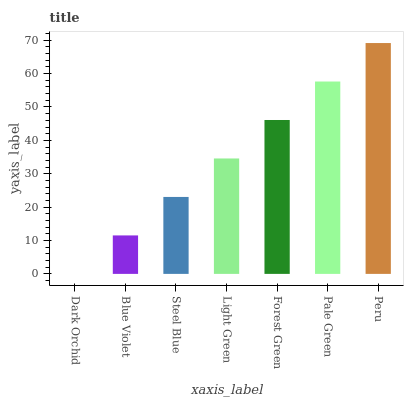Is Dark Orchid the minimum?
Answer yes or no. Yes. Is Peru the maximum?
Answer yes or no. Yes. Is Blue Violet the minimum?
Answer yes or no. No. Is Blue Violet the maximum?
Answer yes or no. No. Is Blue Violet greater than Dark Orchid?
Answer yes or no. Yes. Is Dark Orchid less than Blue Violet?
Answer yes or no. Yes. Is Dark Orchid greater than Blue Violet?
Answer yes or no. No. Is Blue Violet less than Dark Orchid?
Answer yes or no. No. Is Light Green the high median?
Answer yes or no. Yes. Is Light Green the low median?
Answer yes or no. Yes. Is Steel Blue the high median?
Answer yes or no. No. Is Forest Green the low median?
Answer yes or no. No. 